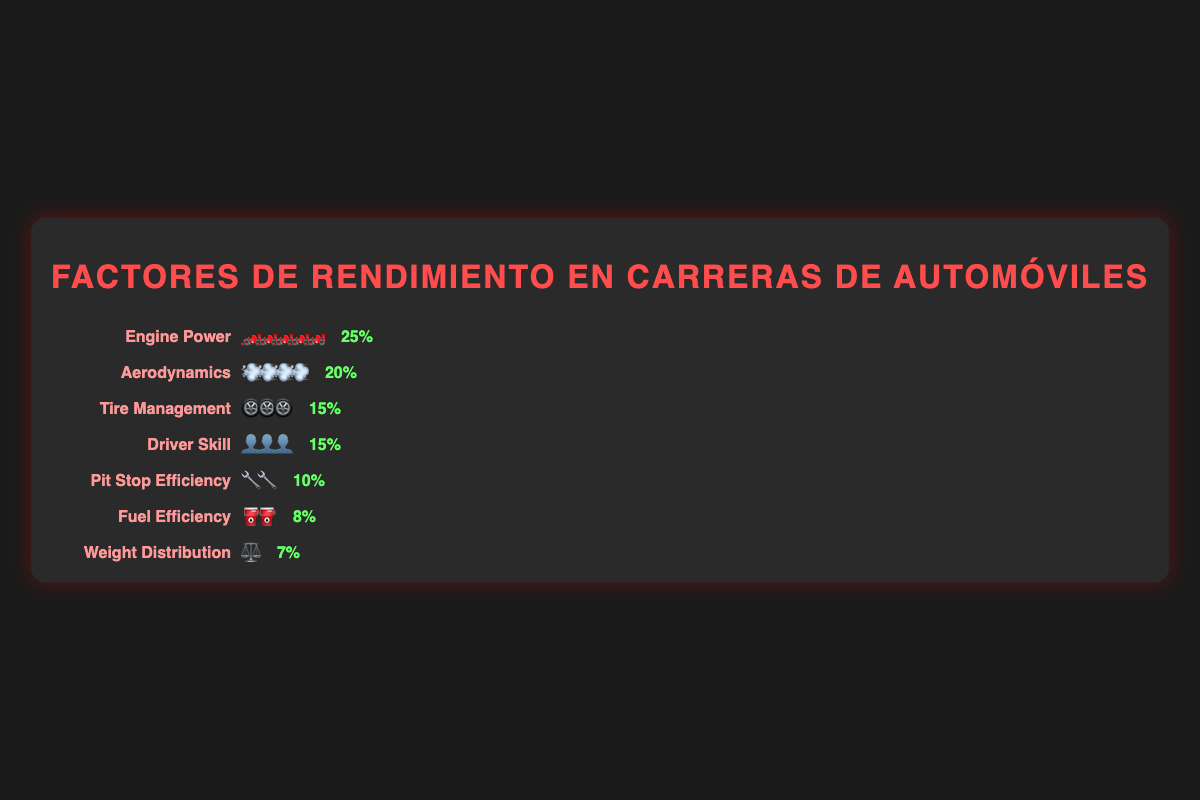Which performance factor has the highest impact percentage? By looking at the impacts listed next to each performance factor, we see that Engine Power has the highest impact at 25%.
Answer: Engine Power What is the combined impact of Tire Management and Driver Skill? Tire Management has an impact of 15% and Driver Skill also has an impact of 15%. Adding these two gives 15% + 15% = 30%.
Answer: 30% How many icons are used to represent the impact of Aerodynamics? The icon 💨 is used to represent Aerodynamics, and there are four of these icons shown on the plot.
Answer: 4 If you sum up the impacts of Pit Stop Efficiency, Fuel Efficiency, and Weight Distribution, what do you get? Pit Stop Efficiency has an impact of 10%, Fuel Efficiency has 8%, and Weight Distribution has 7%. Summing these gives 10% + 8% + 7% = 25%.
Answer: 25% Which two factors have the same impact percentage? By inspecting the impact values, Tire Management and Driver Skill both have an impact percentage of 15%.
Answer: Tire Management and Driver Skill Is the impact of Fuel Efficiency higher or lower than Weight Distribution? Fuel Efficiency has an impact of 8%, whereas Weight Distribution has an impact of 7%, so Fuel Efficiency is higher.
Answer: Higher Which factor is represented with the most number of icons? Engine Power is represented with the most number of icons, with five 🏎️ icons.
Answer: Engine Power What proportion of the total impact does Aerodynamics contribute, considering all factors sum up to 100%? Aerodynamics has an impact of 20%, and since the total is 100%, the proportion is 20/100 = 20%.
Answer: 20% How does the impact of Engine Power compare with the combined impact of Fuel Efficiency and Weight Distribution? Engine Power has an impact of 25%. Combining Fuel Efficiency (8%) and Weight Distribution (7%) gives 15%. Thus, Engine Power's impact is greater than the combined impact.
Answer: Greater What is the visual appearance of the plot's title? The title "Factores de Rendimiento en Carreras de Automóviles" is centered, uppercase, and in red color with a letter-spacing of 2px.
Answer: Centered, uppercase, red 